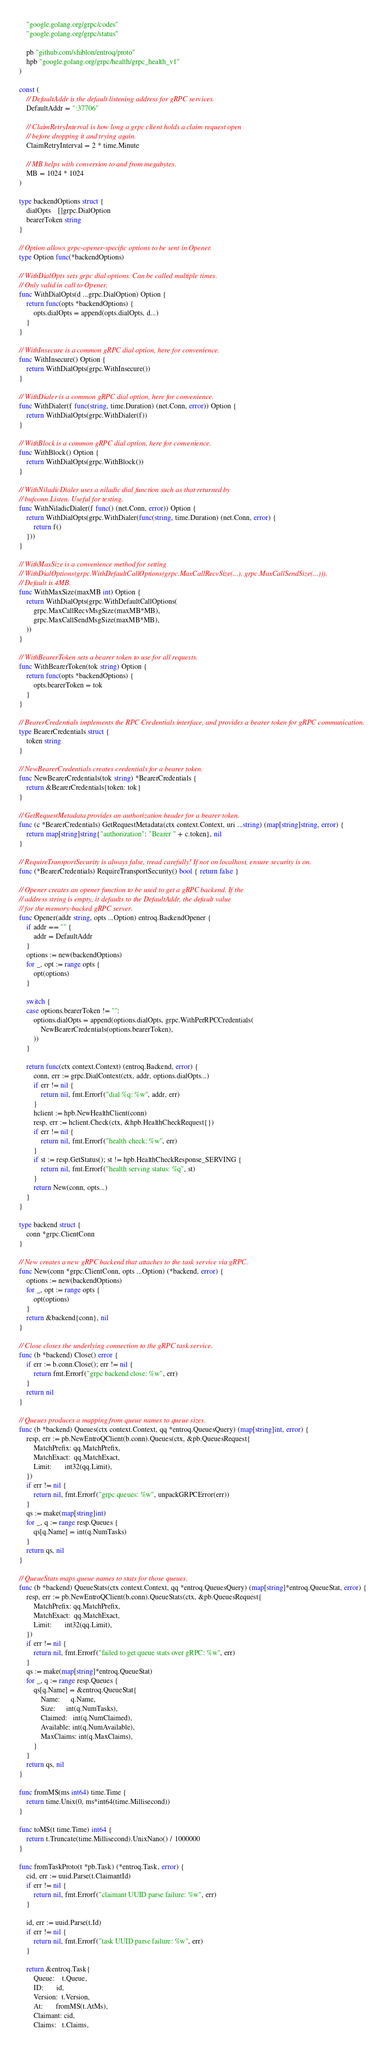<code> <loc_0><loc_0><loc_500><loc_500><_Go_>	"google.golang.org/grpc/codes"
	"google.golang.org/grpc/status"

	pb "github.com/shiblon/entroq/proto"
	hpb "google.golang.org/grpc/health/grpc_health_v1"
)

const (
	// DefaultAddr is the default listening address for gRPC services.
	DefaultAddr = ":37706"

	// ClaimRetryInterval is how long a grpc client holds a claim request open
	// before dropping it and trying again.
	ClaimRetryInterval = 2 * time.Minute

	// MB helps with conversion to and from megabytes.
	MB = 1024 * 1024
)

type backendOptions struct {
	dialOpts    []grpc.DialOption
	bearerToken string
}

// Option allows grpc-opener-specific options to be sent in Opener.
type Option func(*backendOptions)

// WithDialOpts sets grpc dial options. Can be called multiple times.
// Only valid in call to Opener.
func WithDialOpts(d ...grpc.DialOption) Option {
	return func(opts *backendOptions) {
		opts.dialOpts = append(opts.dialOpts, d...)
	}
}

// WithInsecure is a common gRPC dial option, here for convenience.
func WithInsecure() Option {
	return WithDialOpts(grpc.WithInsecure())
}

// WithDialer is a common gRPC dial option, here for convenience.
func WithDialer(f func(string, time.Duration) (net.Conn, error)) Option {
	return WithDialOpts(grpc.WithDialer(f))
}

// WithBlock is a common gRPC dial option, here for convenience.
func WithBlock() Option {
	return WithDialOpts(grpc.WithBlock())
}

// WithNiladicDialer uses a niladic dial function such as that returned by
// bufconn.Listen. Useful for testing.
func WithNiladicDialer(f func() (net.Conn, error)) Option {
	return WithDialOpts(grpc.WithDialer(func(string, time.Duration) (net.Conn, error) {
		return f()
	}))
}

// WithMaxSize is a convenience method for setting
// WithDialOptions(grpc.WithDefaultCallOptions(grpc.MaxCallRecvSize(...), grpc.MaxCallSendSize(...))).
// Default is 4MB.
func WithMaxSize(maxMB int) Option {
	return WithDialOpts(grpc.WithDefaultCallOptions(
		grpc.MaxCallRecvMsgSize(maxMB*MB),
		grpc.MaxCallSendMsgSize(maxMB*MB),
	))
}

// WithBearerToken sets a bearer token to use for all requests.
func WithBearerToken(tok string) Option {
	return func(opts *backendOptions) {
		opts.bearerToken = tok
	}
}

// BearerCredentials implements the RPC Credentials interface, and provides a bearer token for gRPC communication.
type BearerCredentials struct {
	token string
}

// NewBearerCredentials creates credentials for a bearer token.
func NewBearerCredentials(tok string) *BearerCredentials {
	return &BearerCredentials{token: tok}
}

// GetRequestMetadata provides an authorization header for a bearer token.
func (c *BearerCredentials) GetRequestMetadata(ctx context.Context, uri ...string) (map[string]string, error) {
	return map[string]string{"authorization": "Bearer " + c.token}, nil
}

// RequireTransportSecurity is always false, tread carefully! If not on localhost, ensure security is on.
func (*BearerCredentials) RequireTransportSecurity() bool { return false }

// Opener creates an opener function to be used to get a gRPC backend. If the
// address string is empty, it defaults to the DefaultAddr, the default value
// for the memory-backed gRPC server.
func Opener(addr string, opts ...Option) entroq.BackendOpener {
	if addr == "" {
		addr = DefaultAddr
	}
	options := new(backendOptions)
	for _, opt := range opts {
		opt(options)
	}

	switch {
	case options.bearerToken != "":
		options.dialOpts = append(options.dialOpts, grpc.WithPerRPCCredentials(
			NewBearerCredentials(options.bearerToken),
		))
	}

	return func(ctx context.Context) (entroq.Backend, error) {
		conn, err := grpc.DialContext(ctx, addr, options.dialOpts...)
		if err != nil {
			return nil, fmt.Errorf("dial %q: %w", addr, err)
		}
		hclient := hpb.NewHealthClient(conn)
		resp, err := hclient.Check(ctx, &hpb.HealthCheckRequest{})
		if err != nil {
			return nil, fmt.Errorf("health check: %w", err)
		}
		if st := resp.GetStatus(); st != hpb.HealthCheckResponse_SERVING {
			return nil, fmt.Errorf("health serving status: %q", st)
		}
		return New(conn, opts...)
	}
}

type backend struct {
	conn *grpc.ClientConn
}

// New creates a new gRPC backend that attaches to the task service via gRPC.
func New(conn *grpc.ClientConn, opts ...Option) (*backend, error) {
	options := new(backendOptions)
	for _, opt := range opts {
		opt(options)
	}
	return &backend{conn}, nil
}

// Close closes the underlying connection to the gRPC task service.
func (b *backend) Close() error {
	if err := b.conn.Close(); err != nil {
		return fmt.Errorf("grpc backend close: %w", err)
	}
	return nil
}

// Queues produces a mapping from queue names to queue sizes.
func (b *backend) Queues(ctx context.Context, qq *entroq.QueuesQuery) (map[string]int, error) {
	resp, err := pb.NewEntroQClient(b.conn).Queues(ctx, &pb.QueuesRequest{
		MatchPrefix: qq.MatchPrefix,
		MatchExact:  qq.MatchExact,
		Limit:       int32(qq.Limit),
	})
	if err != nil {
		return nil, fmt.Errorf("grpc queues: %w", unpackGRPCError(err))
	}
	qs := make(map[string]int)
	for _, q := range resp.Queues {
		qs[q.Name] = int(q.NumTasks)
	}
	return qs, nil
}

// QueueStats maps queue names to stats for those queues.
func (b *backend) QueueStats(ctx context.Context, qq *entroq.QueuesQuery) (map[string]*entroq.QueueStat, error) {
	resp, err := pb.NewEntroQClient(b.conn).QueueStats(ctx, &pb.QueuesRequest{
		MatchPrefix: qq.MatchPrefix,
		MatchExact:  qq.MatchExact,
		Limit:       int32(qq.Limit),
	})
	if err != nil {
		return nil, fmt.Errorf("failed to get queue stats over gRPC: %w", err)
	}
	qs := make(map[string]*entroq.QueueStat)
	for _, q := range resp.Queues {
		qs[q.Name] = &entroq.QueueStat{
			Name:      q.Name,
			Size:      int(q.NumTasks),
			Claimed:   int(q.NumClaimed),
			Available: int(q.NumAvailable),
			MaxClaims: int(q.MaxClaims),
		}
	}
	return qs, nil
}

func fromMS(ms int64) time.Time {
	return time.Unix(0, ms*int64(time.Millisecond))
}

func toMS(t time.Time) int64 {
	return t.Truncate(time.Millisecond).UnixNano() / 1000000
}

func fromTaskProto(t *pb.Task) (*entroq.Task, error) {
	cid, err := uuid.Parse(t.ClaimantId)
	if err != nil {
		return nil, fmt.Errorf("claimant UUID parse failure: %w", err)
	}

	id, err := uuid.Parse(t.Id)
	if err != nil {
		return nil, fmt.Errorf("task UUID parse failure: %w", err)
	}

	return &entroq.Task{
		Queue:    t.Queue,
		ID:       id,
		Version:  t.Version,
		At:       fromMS(t.AtMs),
		Claimant: cid,
		Claims:   t.Claims,</code> 